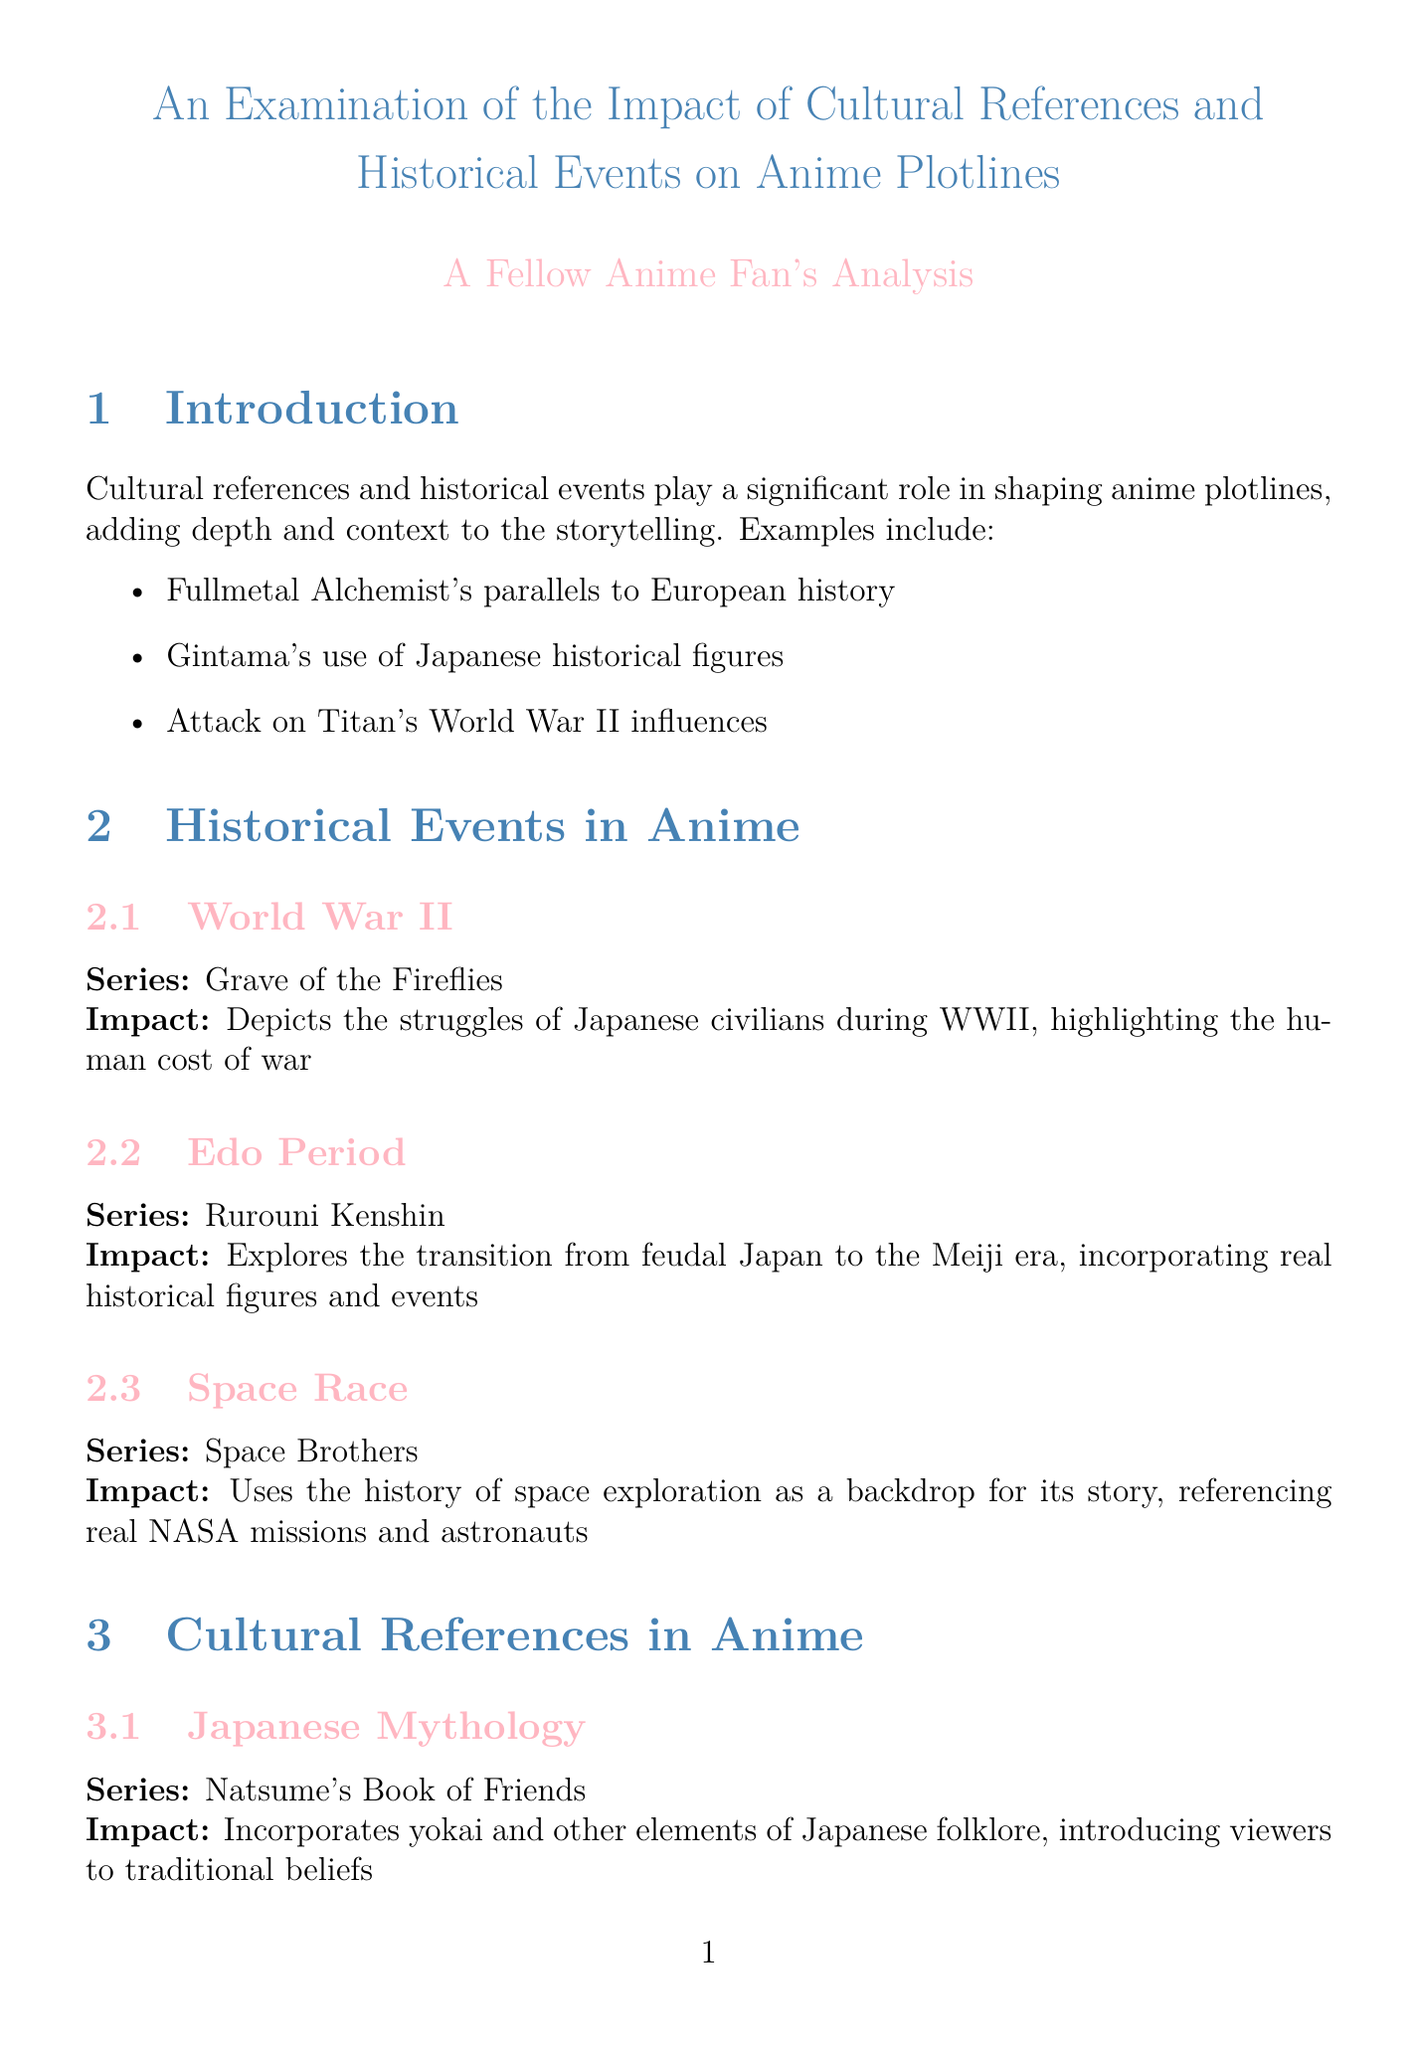What anime series depicts the struggles of Japanese civilians during WWII? The document specifically mentions "Grave of the Fireflies" as the series that depicts these struggles.
Answer: Grave of the Fireflies Which historical period does "Rurouni Kenshin" explore? The document indicates that "Rurouni Kenshin" explores the transition from feudal Japan to the Meiji era.
Answer: Edo Period What is one impact of "Natsume's Book of Friends"? The document states that "Natsume's Book of Friends" incorporates yokai and other elements of Japanese folklore, which introduces viewers to traditional beliefs.
Answer: Introducing viewers to traditional beliefs What educational value does anime have according to the document? The document claims that anime can serve as a gateway to learning about history and culture, encouraging viewers to research referenced events and concepts.
Answer: Gateway to learning about history and culture Which film combines Japanese folklore with environmental themes? According to the document, "Princess Mononoke" is mentioned as the film that blends these themes.
Answer: Princess Mononoke What issue is debated concerning anime portrayals? The document points out that there is a debate over historical accuracy, particularly regarding the portrayal of historical events in anime.
Answer: Historical accuracy How does anime contribute to cultural exchange? The document explains that international viewers gain insights into Japanese history and culture through anime's cultural references.
Answer: Insights into Japanese history and culture What kind of commentary does "Lucky Star" create? The document states that "Lucky Star" creates a meta-commentary on otaku culture through its numerous references to anime, manga, and Japanese pop culture.
Answer: Meta-commentary on otaku culture What ongoing influence does the report mention about modern anime? The document notes that the integration of cultural references and historical events continues to evolve in modern anime.
Answer: Evolving integration of cultural references and historical events 